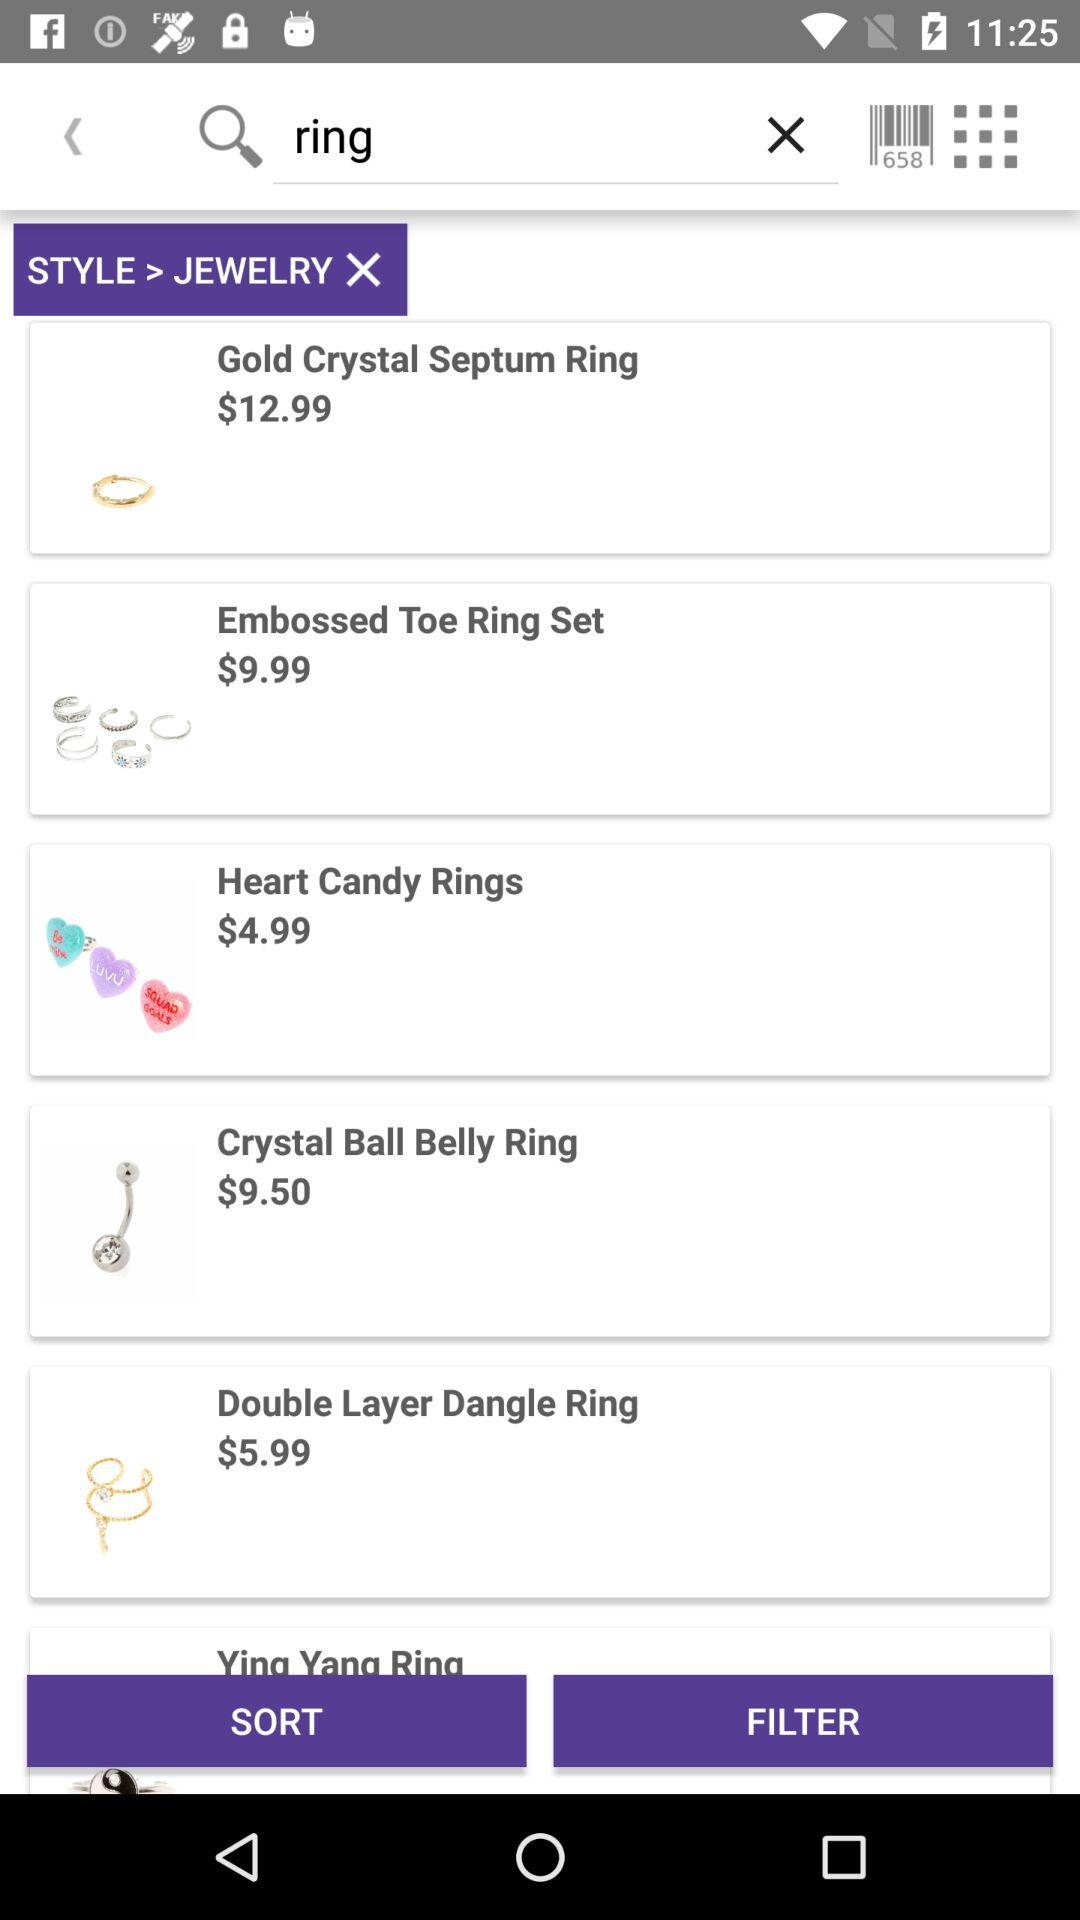What is the currency of price? The currency of price is the dollar. 